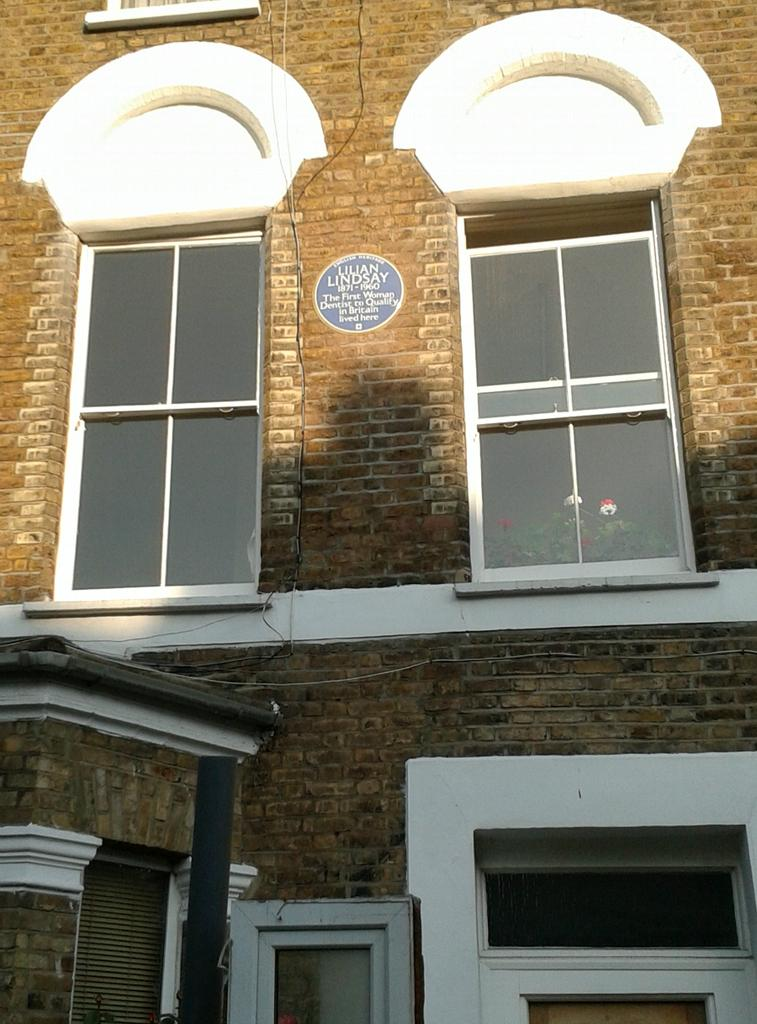What structure is present in the image? There is a building in the image. What feature can be seen on the building? The building has windows. What type of stem is visible in the image? There is no stem present in the image; it features a building with windows. Is the building involved in a fight in the image? There is no indication of a fight or any conflict in the image, as it only shows a building with windows. 